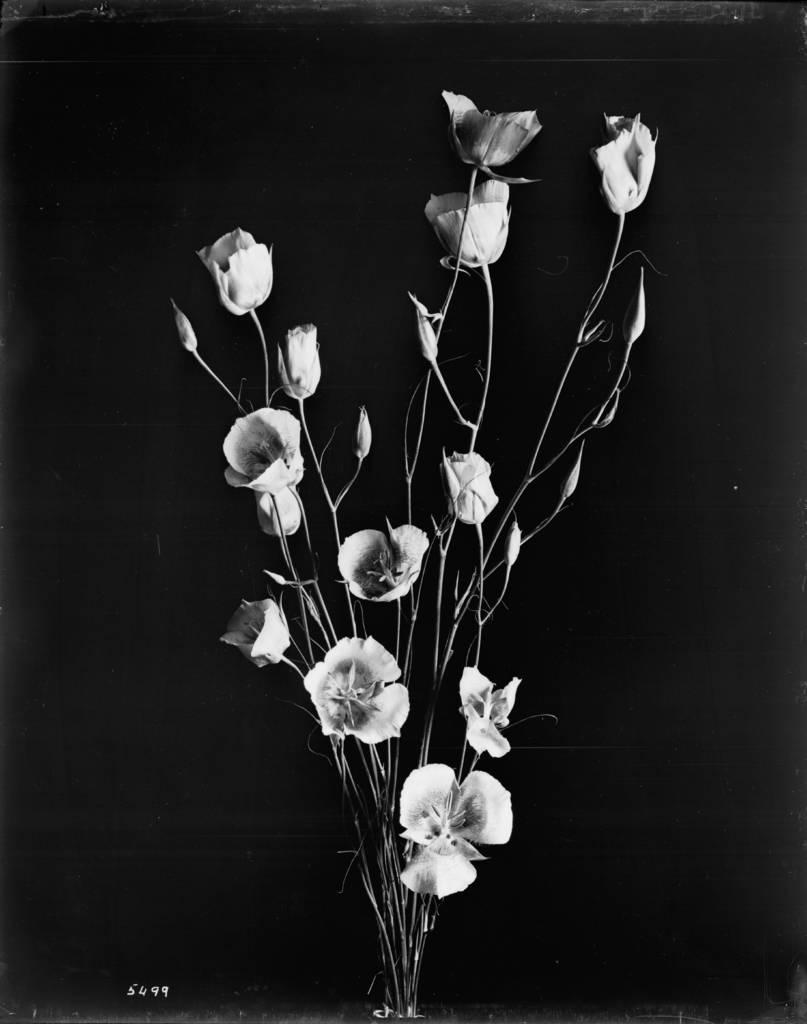What is the color scheme of the image? The image is black and white. Can you see any crates floating in the ocean in the image? There is no ocean or crates present in the image; it features a black and white scene with plants, stems, leaves, and flower buds. Is there a prison visible in the image? There is no prison present in the image; it focuses on natural elements and numbers at the bottom. 